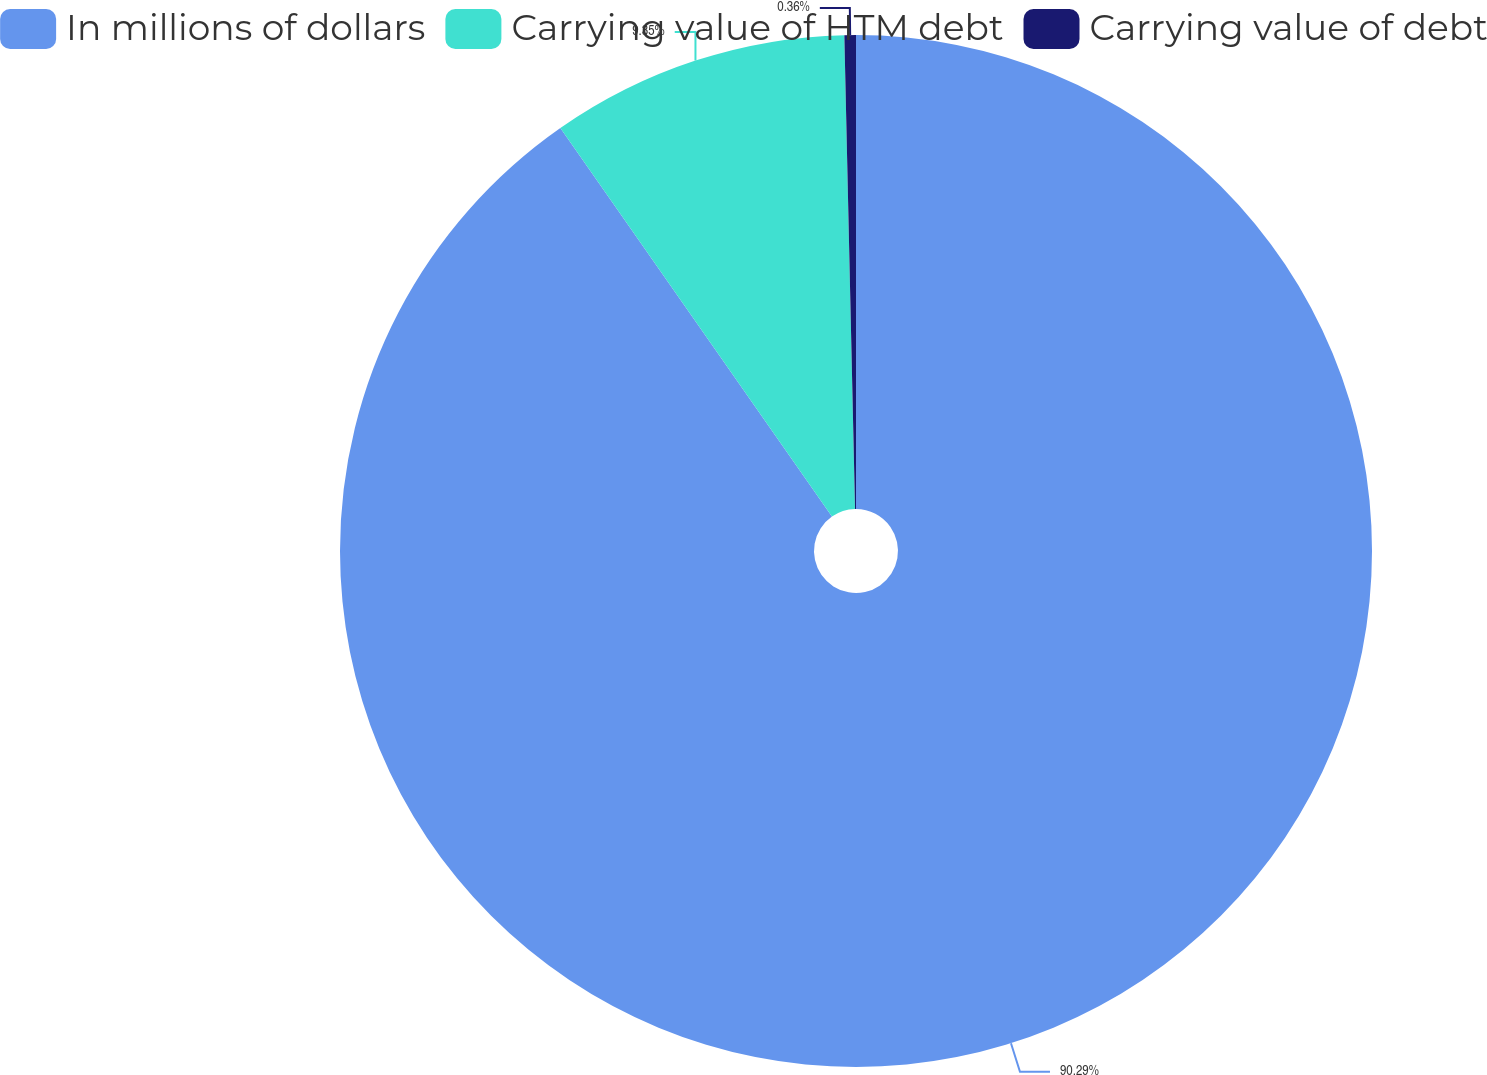<chart> <loc_0><loc_0><loc_500><loc_500><pie_chart><fcel>In millions of dollars<fcel>Carrying value of HTM debt<fcel>Carrying value of debt<nl><fcel>90.29%<fcel>9.35%<fcel>0.36%<nl></chart> 